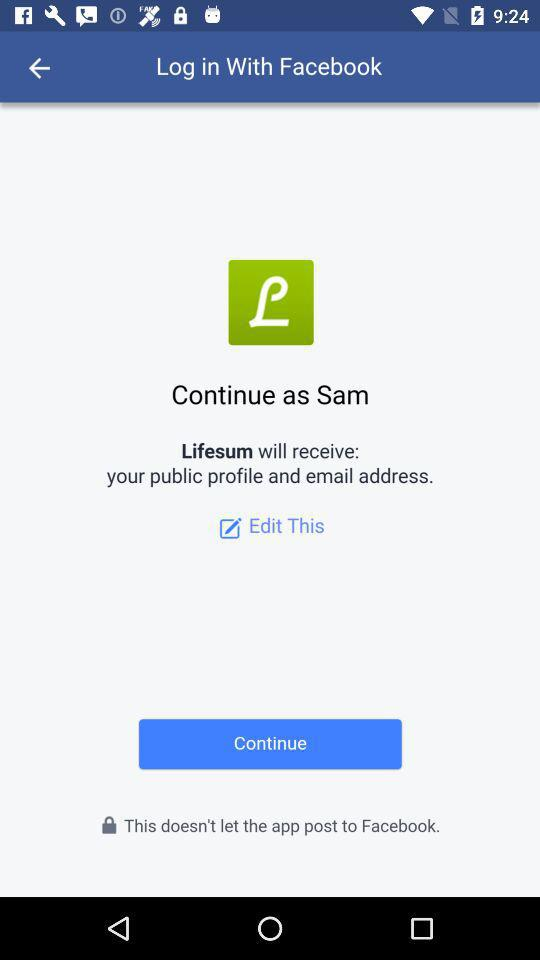What is the name of the user? The name of the user is Sam. 